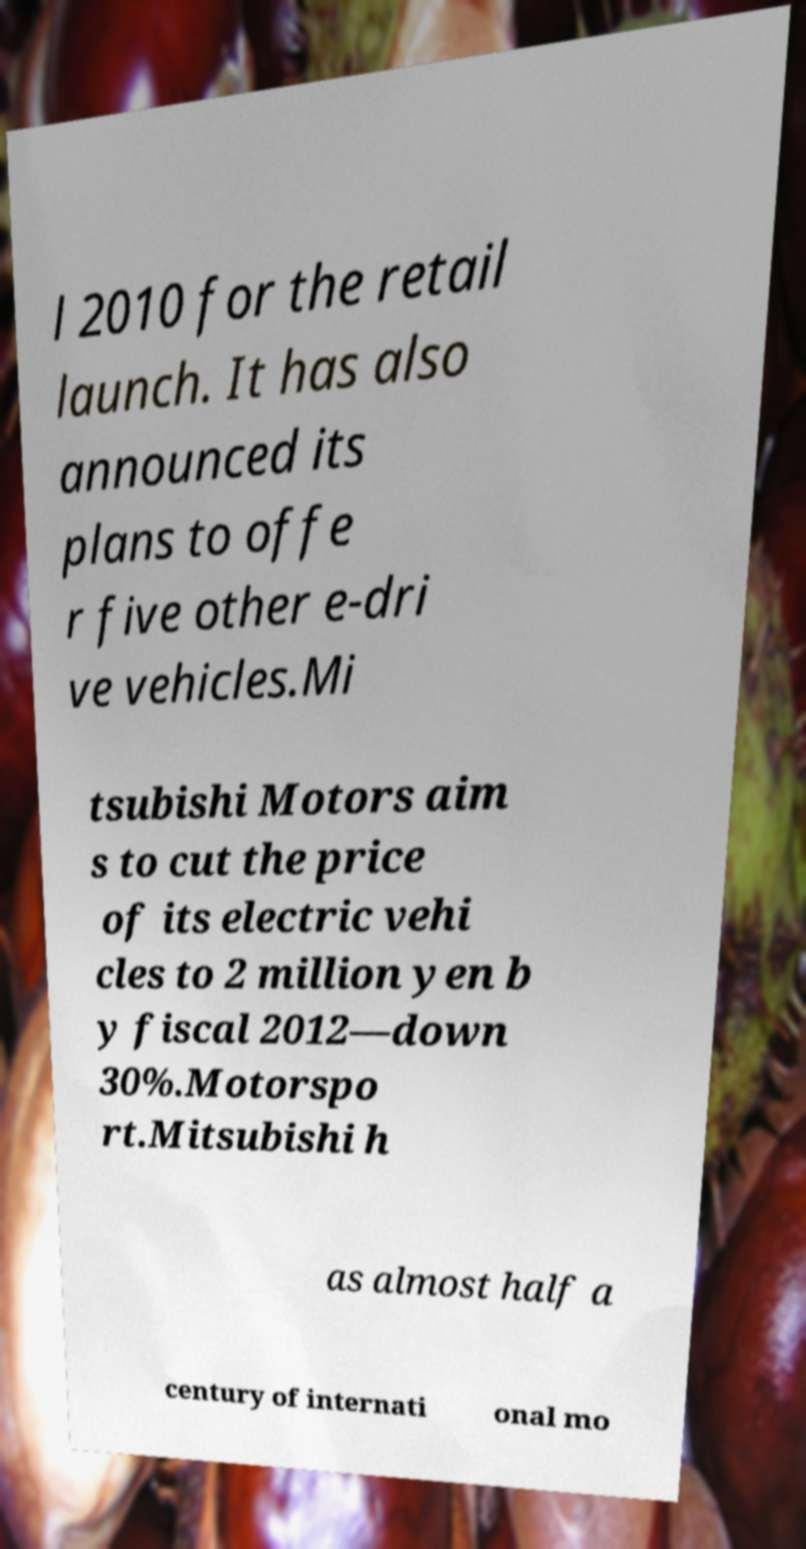For documentation purposes, I need the text within this image transcribed. Could you provide that? l 2010 for the retail launch. It has also announced its plans to offe r five other e-dri ve vehicles.Mi tsubishi Motors aim s to cut the price of its electric vehi cles to 2 million yen b y fiscal 2012—down 30%.Motorspo rt.Mitsubishi h as almost half a century of internati onal mo 